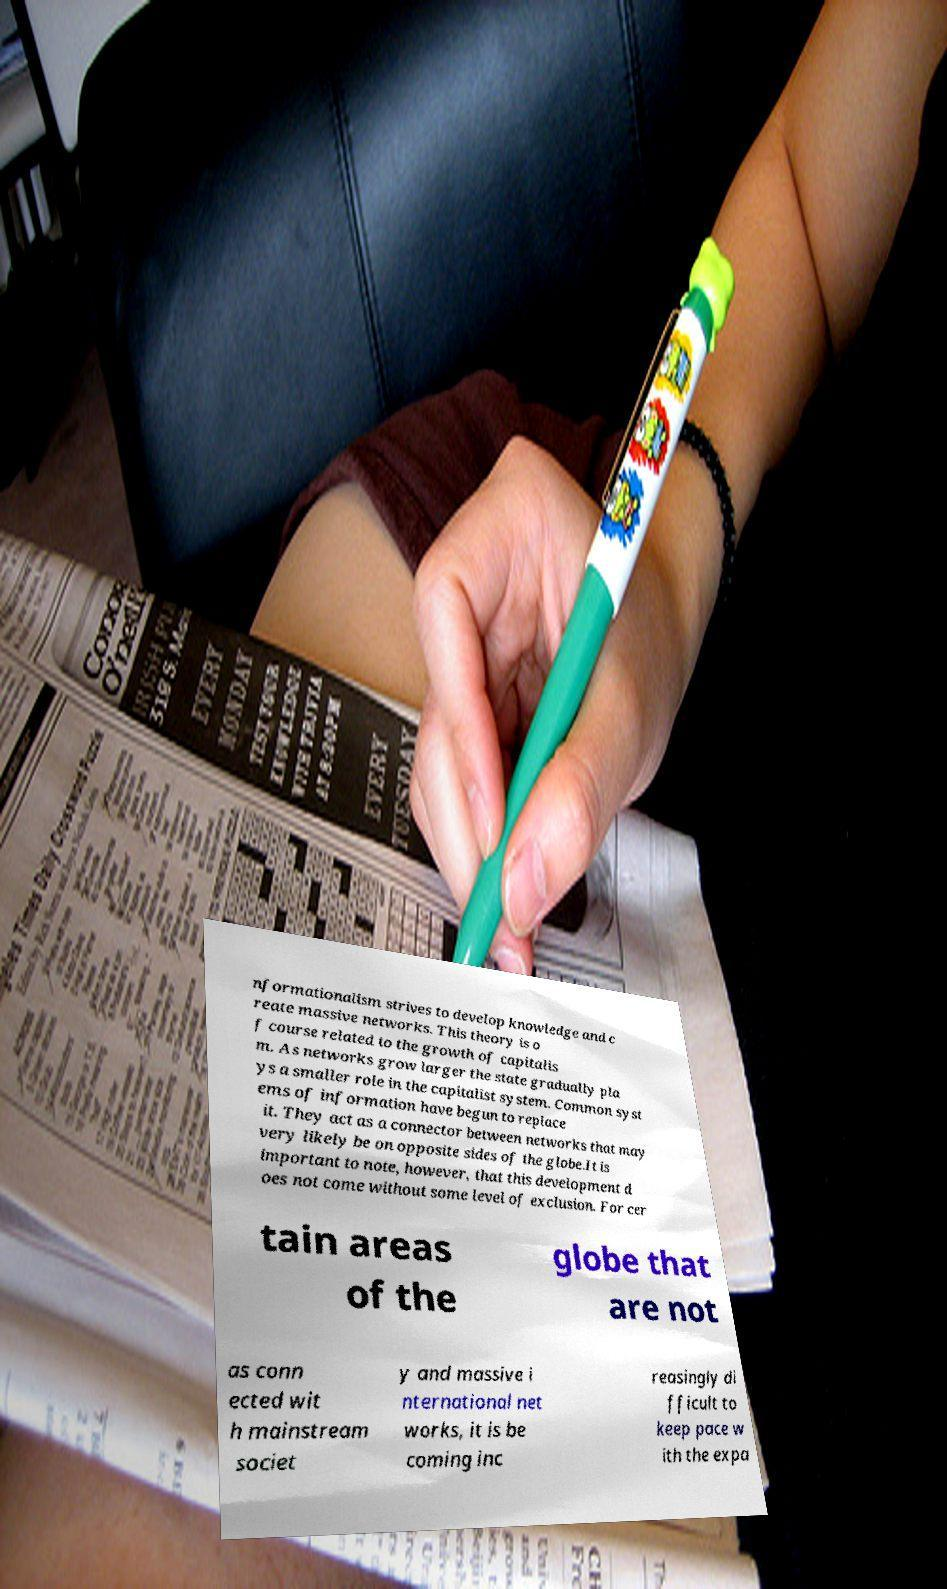What messages or text are displayed in this image? I need them in a readable, typed format. nformationalism strives to develop knowledge and c reate massive networks. This theory is o f course related to the growth of capitalis m. As networks grow larger the state gradually pla ys a smaller role in the capitalist system. Common syst ems of information have begun to replace it. They act as a connector between networks that may very likely be on opposite sides of the globe.It is important to note, however, that this development d oes not come without some level of exclusion. For cer tain areas of the globe that are not as conn ected wit h mainstream societ y and massive i nternational net works, it is be coming inc reasingly di fficult to keep pace w ith the expa 